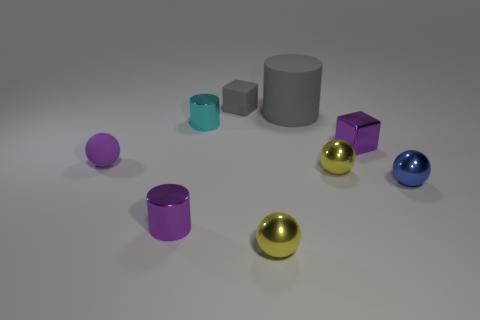There is a matte object that is behind the large gray object; does it have the same shape as the purple object that is in front of the purple ball?
Provide a short and direct response. No. Is there a small cyan cylinder?
Your response must be concise. Yes. The other shiny object that is the same shape as the cyan metal object is what color?
Your response must be concise. Purple. What color is the other shiny cylinder that is the same size as the cyan metallic cylinder?
Your response must be concise. Purple. Are the big gray cylinder and the tiny cyan object made of the same material?
Ensure brevity in your answer.  No. What number of other cubes have the same color as the small metallic cube?
Give a very brief answer. 0. Do the large object and the tiny rubber cube have the same color?
Provide a succinct answer. Yes. What is the tiny block behind the tiny cyan object made of?
Your answer should be very brief. Rubber. How many tiny objects are metal cubes or purple metal cylinders?
Make the answer very short. 2. There is a big thing that is the same color as the matte block; what is it made of?
Provide a short and direct response. Rubber. 